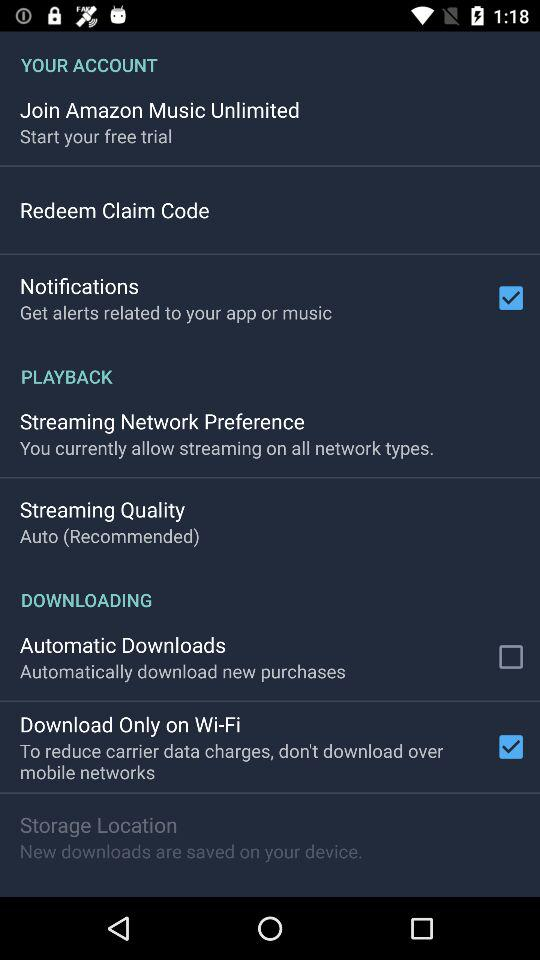What is the status of "Notifications"? The status is "on". 